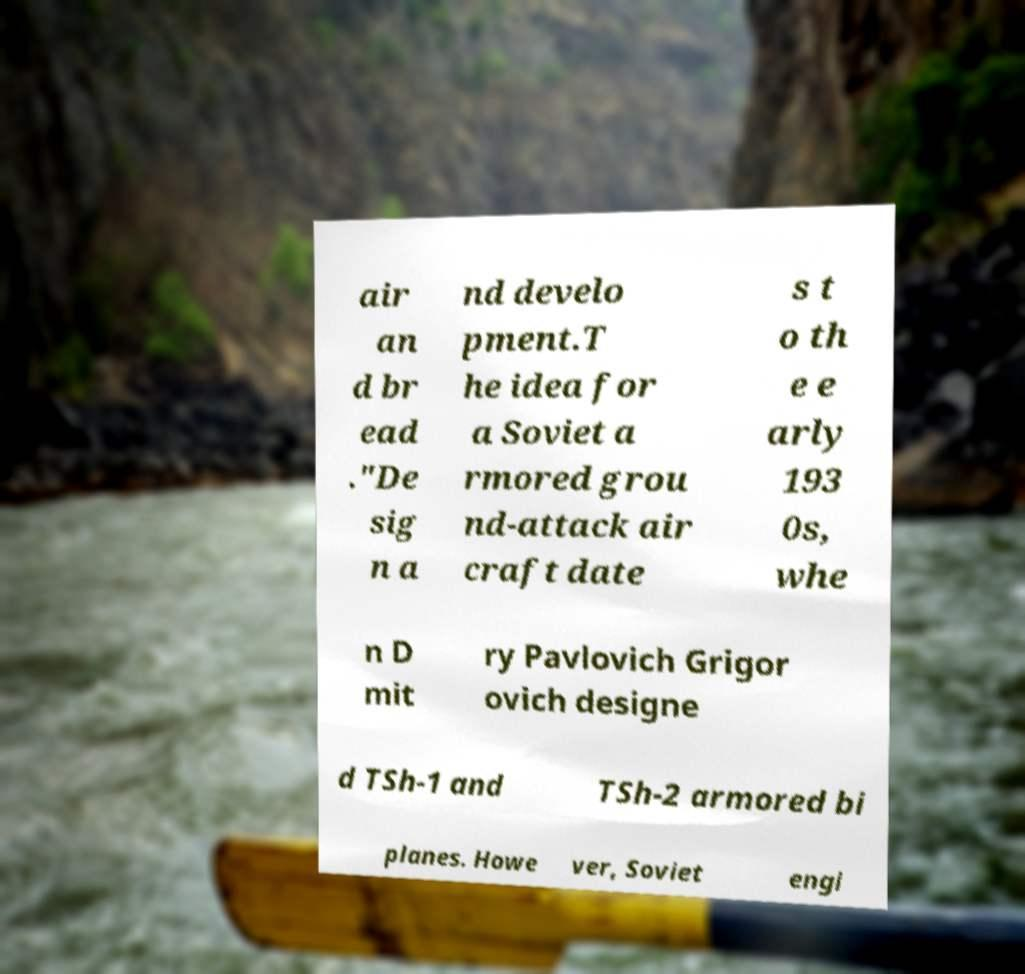I need the written content from this picture converted into text. Can you do that? air an d br ead ."De sig n a nd develo pment.T he idea for a Soviet a rmored grou nd-attack air craft date s t o th e e arly 193 0s, whe n D mit ry Pavlovich Grigor ovich designe d TSh-1 and TSh-2 armored bi planes. Howe ver, Soviet engi 